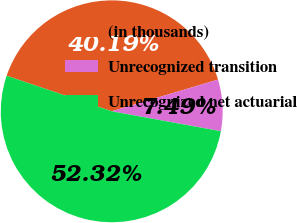Convert chart. <chart><loc_0><loc_0><loc_500><loc_500><pie_chart><fcel>(in thousands)<fcel>Unrecognized transition<fcel>Unrecognized net actuarial<nl><fcel>40.19%<fcel>7.49%<fcel>52.31%<nl></chart> 